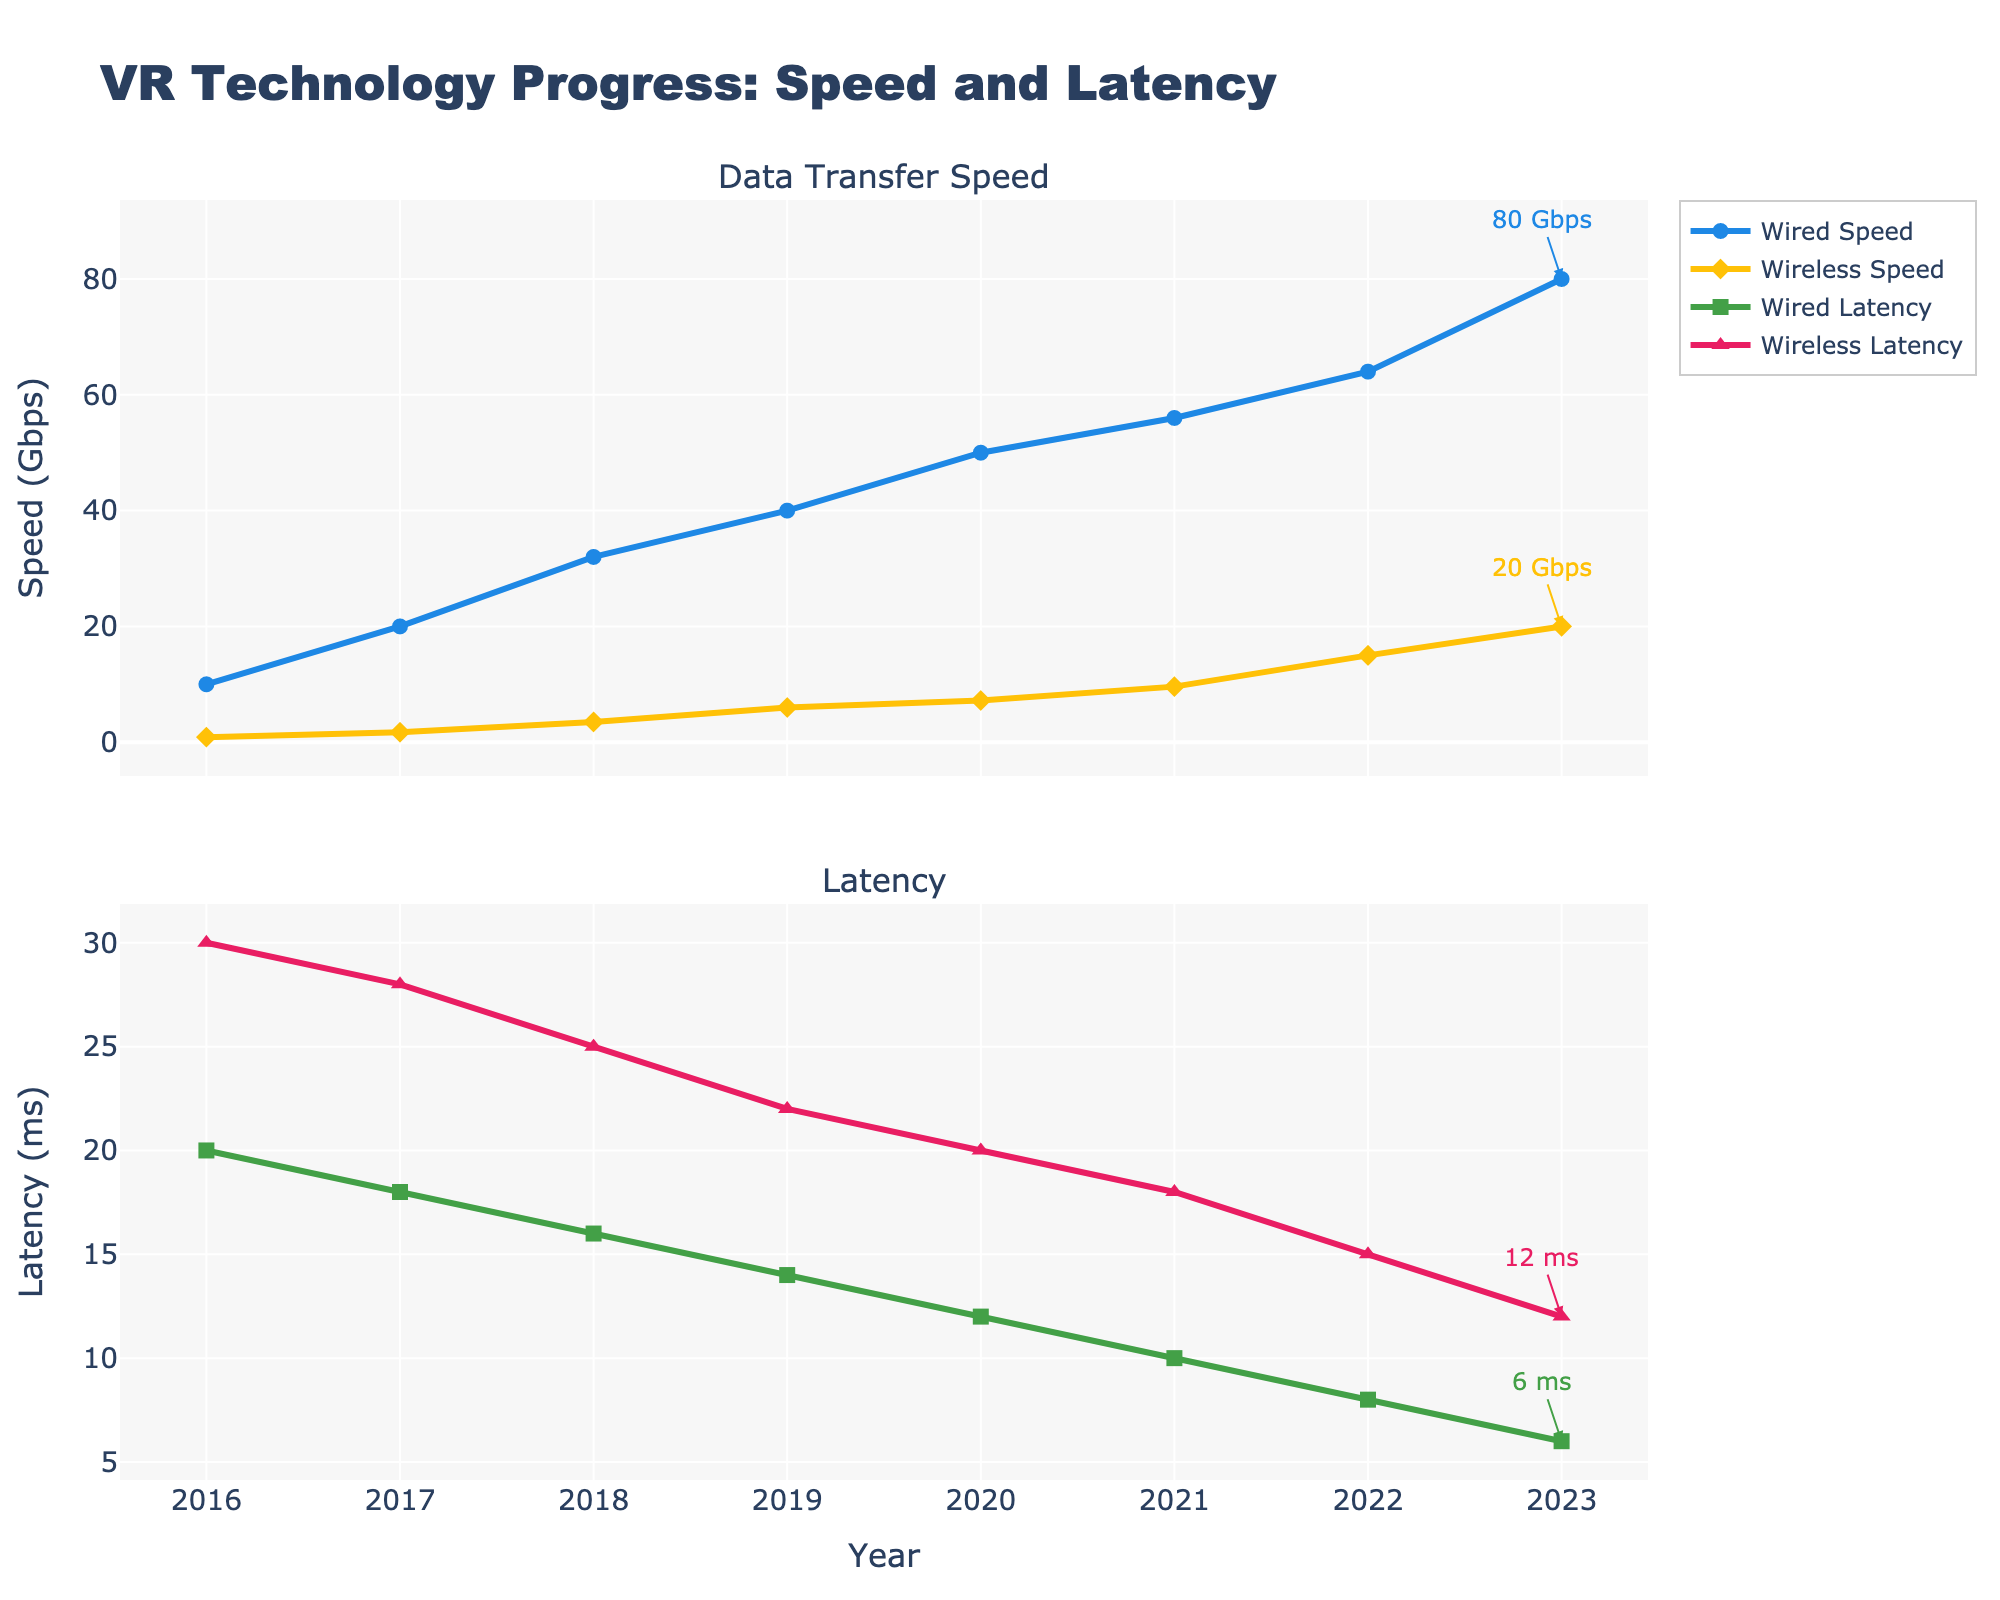What is the difference in wired speed between 2016 and 2023? The wired speed in 2016 is 10 Gbps and in 2023 is 80 Gbps. By subtracting 10 from 80, we get 70 Gbps.
Answer: 70 Gbps What is the average latency for wireless solutions in 2020 and 2021? The wireless latency in 2020 is 20 ms and in 2021 is 18 ms. The average is calculated by adding these two values and dividing by 2, yielding (20 + 18)/2 = 19 ms.
Answer: 19 ms Which year shows the highest increase in wireless speed compared to the previous year? By comparing year-over-year differences: 
- 2017-2016: 1.733 - 0.867 = 0.866 Gbps
- 2018-2017: 3.5 - 1.733 = 1.767 Gbps
- 2019-2018: 6 - 3.5 = 2.5 Gbps
- 2020-2019: 7.2 - 6 = 1.2 Gbps
- 2021-2020: 9.6 - 7.2 = 2.4 Gbps
- 2022-2021: 15 - 9.6 = 5.4 Gbps
- 2023-2022: 20 - 15 = 5 Gbps
The highest increase is from 2021 to 2022 with 5.4 Gbps.
Answer: 2022 Is wireless latency in 2023 higher or lower than wired latency in 2019? Wireless latency in 2023 is 12 ms while wired latency in 2019 is 14 ms. Since 12 ms is less than 14 ms, wireless latency in 2023 is lower.
Answer: Lower How much did wireless speed improve from 2017 to 2023? The wireless speed in 2017 is 1.733 Gbps and in 2023 is 20 Gbps. The improvement is calculated by subtracting 1.733 from 20, yielding 20 - 1.733 = 18.267 Gbps.
Answer: 18.267 Gbps What is the median wired latency across the years shown? Ordered latencies are: 6, 8, 10, 12, 14, 16, 18, 20. The middle values are 12 and 14. The median is the average of these two values: (12 + 14)/2 = 13 ms.
Answer: 13 ms Which has had a greater cumulative improvement from 2016 to 2023, wired speed or wireless speed? Wired speed improvement: 80 Gbps (2023) - 10 Gbps (2016) = 70 Gbps. 
Wireless speed improvement: 20 Gbps (2023) - 0.867 Gbps (2016) = 19.133 Gbps. 
Wired speed improvement is greater.
Answer: Wired speed What was the wired speed in 2018 compared to the wireless speed in 2020? Wired speed in 2018 is 32 Gbps and wireless speed in 2020 is 7.2 Gbps. 32 Gbps is greater than 7.2 Gbps.
Answer: Greater By how much did the wired latency decrease from 2016 to 2023? Wired latency in 2016 is 20 ms and in 2023 is 6 ms. The decrease is calculated by subtracting 6 from 20, yielding 20 - 6 = 14 ms.
Answer: 14 ms 